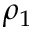<formula> <loc_0><loc_0><loc_500><loc_500>\rho _ { 1 }</formula> 